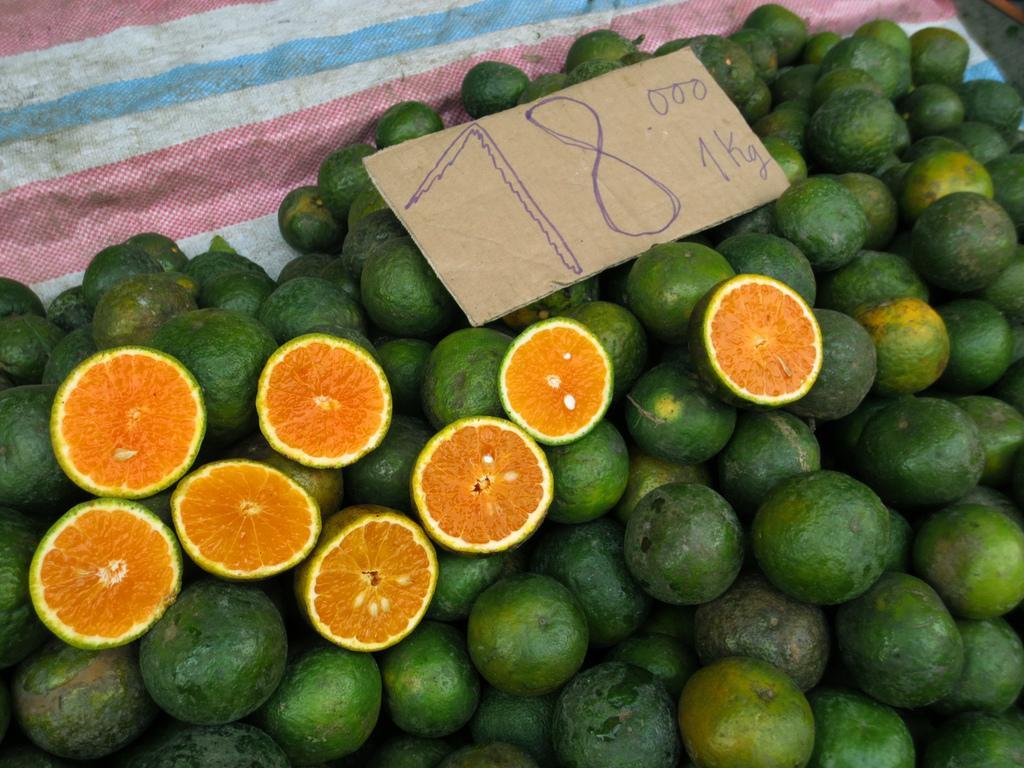Could you give a brief overview of what you see in this image? In the foreground of this picture, there are oranges and few cut pieces of it on a cloth. There is also a price board on it. 